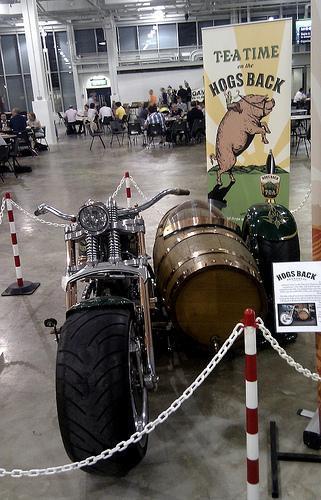How many vehicles are in this photo?
Give a very brief answer. 1. 